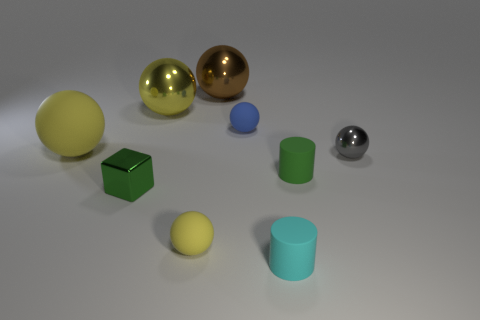How many small matte balls are the same color as the tiny shiny sphere?
Provide a short and direct response. 0. How big is the cylinder that is behind the tiny rubber cylinder that is in front of the green block?
Provide a short and direct response. Small. What number of things are matte balls that are to the left of the block or large brown balls?
Provide a succinct answer. 2. Are there any matte things that have the same size as the cube?
Your answer should be very brief. Yes. Are there any small green things to the left of the green object on the left side of the blue matte sphere?
Keep it short and to the point. No. What number of cubes are metal things or small things?
Keep it short and to the point. 1. Is there a big yellow rubber thing that has the same shape as the tiny yellow matte thing?
Your response must be concise. Yes. The large brown object has what shape?
Your answer should be very brief. Sphere. How many things are gray metallic spheres or brown spheres?
Keep it short and to the point. 2. There is a shiny object that is to the right of the big brown shiny thing; is its size the same as the cyan matte cylinder that is in front of the brown metallic sphere?
Offer a very short reply. Yes. 